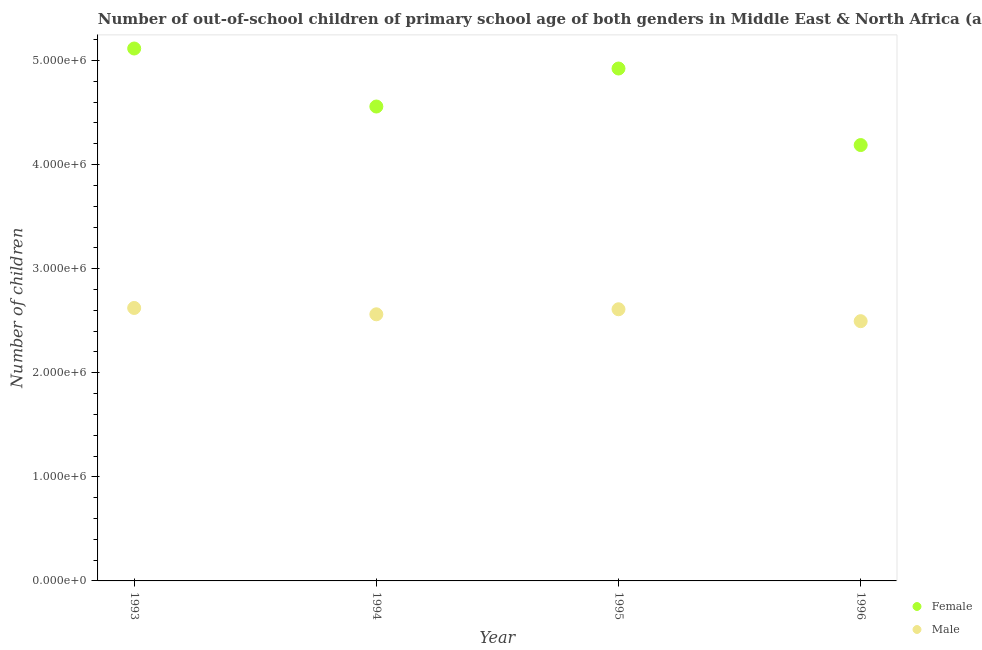How many different coloured dotlines are there?
Offer a terse response. 2. Is the number of dotlines equal to the number of legend labels?
Keep it short and to the point. Yes. What is the number of male out-of-school students in 1996?
Provide a short and direct response. 2.50e+06. Across all years, what is the maximum number of male out-of-school students?
Keep it short and to the point. 2.62e+06. Across all years, what is the minimum number of male out-of-school students?
Provide a short and direct response. 2.50e+06. In which year was the number of male out-of-school students maximum?
Offer a terse response. 1993. What is the total number of female out-of-school students in the graph?
Offer a terse response. 1.88e+07. What is the difference between the number of female out-of-school students in 1995 and that in 1996?
Your answer should be very brief. 7.35e+05. What is the difference between the number of female out-of-school students in 1996 and the number of male out-of-school students in 1995?
Your answer should be very brief. 1.58e+06. What is the average number of female out-of-school students per year?
Keep it short and to the point. 4.70e+06. In the year 1994, what is the difference between the number of female out-of-school students and number of male out-of-school students?
Provide a succinct answer. 2.00e+06. In how many years, is the number of male out-of-school students greater than 3200000?
Keep it short and to the point. 0. What is the ratio of the number of male out-of-school students in 1994 to that in 1996?
Your response must be concise. 1.03. Is the difference between the number of female out-of-school students in 1994 and 1996 greater than the difference between the number of male out-of-school students in 1994 and 1996?
Provide a succinct answer. Yes. What is the difference between the highest and the second highest number of female out-of-school students?
Offer a very short reply. 1.92e+05. What is the difference between the highest and the lowest number of female out-of-school students?
Provide a succinct answer. 9.28e+05. Is the sum of the number of male out-of-school students in 1994 and 1996 greater than the maximum number of female out-of-school students across all years?
Your answer should be very brief. No. Does the number of female out-of-school students monotonically increase over the years?
Your answer should be very brief. No. Is the number of male out-of-school students strictly greater than the number of female out-of-school students over the years?
Provide a short and direct response. No. Is the number of male out-of-school students strictly less than the number of female out-of-school students over the years?
Provide a short and direct response. Yes. How many dotlines are there?
Your answer should be compact. 2. How many years are there in the graph?
Your response must be concise. 4. Where does the legend appear in the graph?
Provide a short and direct response. Bottom right. How many legend labels are there?
Provide a succinct answer. 2. How are the legend labels stacked?
Make the answer very short. Vertical. What is the title of the graph?
Make the answer very short. Number of out-of-school children of primary school age of both genders in Middle East & North Africa (all income levels). Does "GDP at market prices" appear as one of the legend labels in the graph?
Keep it short and to the point. No. What is the label or title of the X-axis?
Your answer should be compact. Year. What is the label or title of the Y-axis?
Provide a succinct answer. Number of children. What is the Number of children of Female in 1993?
Offer a terse response. 5.11e+06. What is the Number of children in Male in 1993?
Your response must be concise. 2.62e+06. What is the Number of children in Female in 1994?
Your answer should be very brief. 4.56e+06. What is the Number of children in Male in 1994?
Your answer should be compact. 2.56e+06. What is the Number of children of Female in 1995?
Keep it short and to the point. 4.92e+06. What is the Number of children of Male in 1995?
Your answer should be compact. 2.61e+06. What is the Number of children of Female in 1996?
Make the answer very short. 4.19e+06. What is the Number of children in Male in 1996?
Your response must be concise. 2.50e+06. Across all years, what is the maximum Number of children of Female?
Make the answer very short. 5.11e+06. Across all years, what is the maximum Number of children of Male?
Give a very brief answer. 2.62e+06. Across all years, what is the minimum Number of children of Female?
Make the answer very short. 4.19e+06. Across all years, what is the minimum Number of children in Male?
Your answer should be compact. 2.50e+06. What is the total Number of children in Female in the graph?
Your response must be concise. 1.88e+07. What is the total Number of children in Male in the graph?
Provide a short and direct response. 1.03e+07. What is the difference between the Number of children of Female in 1993 and that in 1994?
Keep it short and to the point. 5.57e+05. What is the difference between the Number of children in Male in 1993 and that in 1994?
Offer a very short reply. 6.09e+04. What is the difference between the Number of children of Female in 1993 and that in 1995?
Offer a terse response. 1.92e+05. What is the difference between the Number of children of Male in 1993 and that in 1995?
Offer a very short reply. 1.25e+04. What is the difference between the Number of children in Female in 1993 and that in 1996?
Offer a terse response. 9.28e+05. What is the difference between the Number of children of Male in 1993 and that in 1996?
Your response must be concise. 1.27e+05. What is the difference between the Number of children in Female in 1994 and that in 1995?
Offer a terse response. -3.65e+05. What is the difference between the Number of children of Male in 1994 and that in 1995?
Your answer should be very brief. -4.84e+04. What is the difference between the Number of children of Female in 1994 and that in 1996?
Offer a very short reply. 3.70e+05. What is the difference between the Number of children of Male in 1994 and that in 1996?
Your answer should be very brief. 6.60e+04. What is the difference between the Number of children of Female in 1995 and that in 1996?
Give a very brief answer. 7.35e+05. What is the difference between the Number of children in Male in 1995 and that in 1996?
Your answer should be compact. 1.14e+05. What is the difference between the Number of children in Female in 1993 and the Number of children in Male in 1994?
Make the answer very short. 2.55e+06. What is the difference between the Number of children of Female in 1993 and the Number of children of Male in 1995?
Your response must be concise. 2.51e+06. What is the difference between the Number of children of Female in 1993 and the Number of children of Male in 1996?
Ensure brevity in your answer.  2.62e+06. What is the difference between the Number of children of Female in 1994 and the Number of children of Male in 1995?
Offer a terse response. 1.95e+06. What is the difference between the Number of children of Female in 1994 and the Number of children of Male in 1996?
Make the answer very short. 2.06e+06. What is the difference between the Number of children in Female in 1995 and the Number of children in Male in 1996?
Your answer should be compact. 2.43e+06. What is the average Number of children of Female per year?
Your answer should be very brief. 4.70e+06. What is the average Number of children in Male per year?
Offer a very short reply. 2.57e+06. In the year 1993, what is the difference between the Number of children of Female and Number of children of Male?
Provide a succinct answer. 2.49e+06. In the year 1994, what is the difference between the Number of children in Female and Number of children in Male?
Offer a very short reply. 2.00e+06. In the year 1995, what is the difference between the Number of children in Female and Number of children in Male?
Keep it short and to the point. 2.31e+06. In the year 1996, what is the difference between the Number of children in Female and Number of children in Male?
Make the answer very short. 1.69e+06. What is the ratio of the Number of children in Female in 1993 to that in 1994?
Make the answer very short. 1.12. What is the ratio of the Number of children of Male in 1993 to that in 1994?
Offer a very short reply. 1.02. What is the ratio of the Number of children of Female in 1993 to that in 1995?
Ensure brevity in your answer.  1.04. What is the ratio of the Number of children in Female in 1993 to that in 1996?
Your answer should be compact. 1.22. What is the ratio of the Number of children of Male in 1993 to that in 1996?
Your response must be concise. 1.05. What is the ratio of the Number of children in Female in 1994 to that in 1995?
Offer a very short reply. 0.93. What is the ratio of the Number of children in Male in 1994 to that in 1995?
Keep it short and to the point. 0.98. What is the ratio of the Number of children in Female in 1994 to that in 1996?
Provide a short and direct response. 1.09. What is the ratio of the Number of children of Male in 1994 to that in 1996?
Offer a very short reply. 1.03. What is the ratio of the Number of children of Female in 1995 to that in 1996?
Provide a succinct answer. 1.18. What is the ratio of the Number of children in Male in 1995 to that in 1996?
Your answer should be compact. 1.05. What is the difference between the highest and the second highest Number of children of Female?
Give a very brief answer. 1.92e+05. What is the difference between the highest and the second highest Number of children in Male?
Your answer should be compact. 1.25e+04. What is the difference between the highest and the lowest Number of children in Female?
Your answer should be compact. 9.28e+05. What is the difference between the highest and the lowest Number of children of Male?
Offer a very short reply. 1.27e+05. 